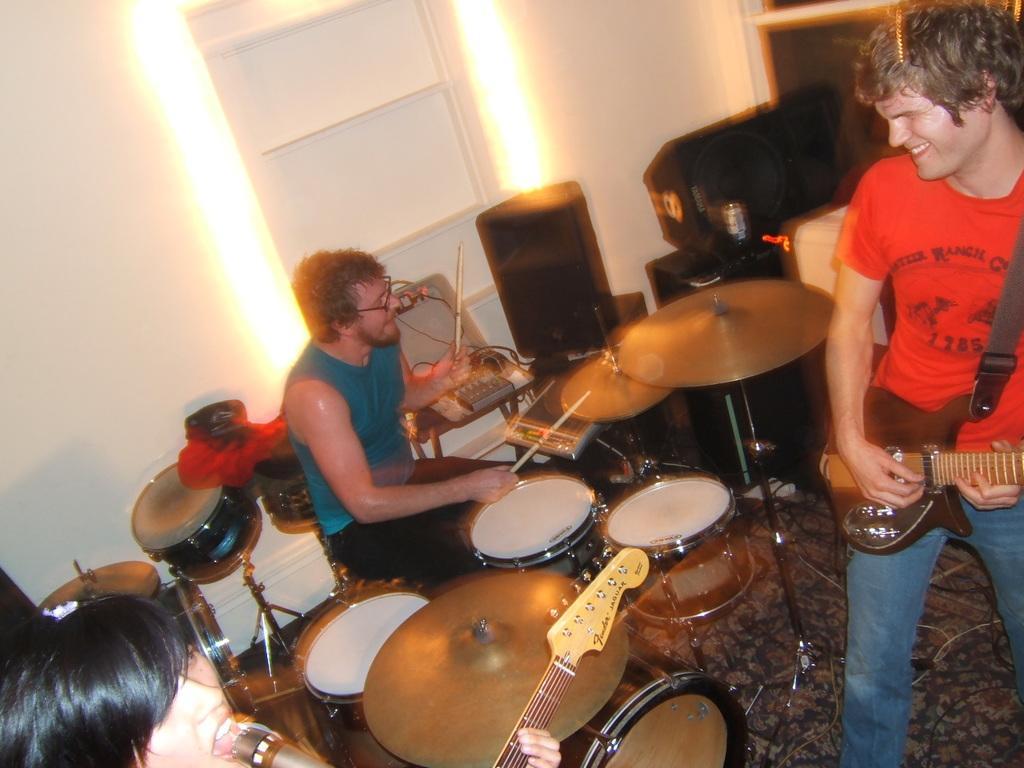In one or two sentences, can you explain what this image depicts? In the image we can see the three persons. In the center we can see one man sitting and he is holding stick. Coming to the right side we can see one man, he is smiling and he is holding guitar. Coming to the left side we can see one person he is singing. In front of him we can see the microphone. And they were surrounded by musical instruments. Coming to the background we can see the wall and door. 